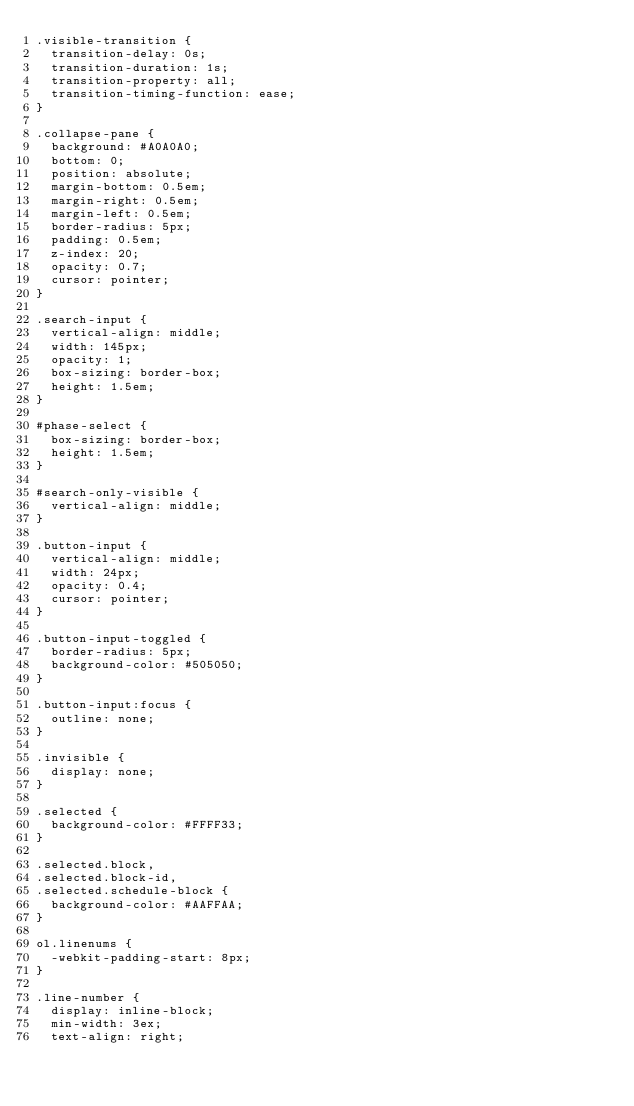Convert code to text. <code><loc_0><loc_0><loc_500><loc_500><_CSS_>.visible-transition {
  transition-delay: 0s;
  transition-duration: 1s;
  transition-property: all;
  transition-timing-function: ease;
}

.collapse-pane {
  background: #A0A0A0;
  bottom: 0;
  position: absolute;
  margin-bottom: 0.5em;
  margin-right: 0.5em;
  margin-left: 0.5em;
  border-radius: 5px;
  padding: 0.5em;
  z-index: 20;
  opacity: 0.7;
  cursor: pointer;
}

.search-input {
  vertical-align: middle;
  width: 145px;
  opacity: 1;
  box-sizing: border-box;
  height: 1.5em;
}

#phase-select {
  box-sizing: border-box;
  height: 1.5em;
}

#search-only-visible {
  vertical-align: middle;
}

.button-input {
  vertical-align: middle;
  width: 24px;
  opacity: 0.4;
  cursor: pointer;
}

.button-input-toggled {
  border-radius: 5px;
  background-color: #505050;
}

.button-input:focus {
  outline: none;
}

.invisible {
  display: none;
}

.selected {
  background-color: #FFFF33;
}

.selected.block,
.selected.block-id,
.selected.schedule-block {
  background-color: #AAFFAA;
}

ol.linenums {
  -webkit-padding-start: 8px;
}

.line-number {
  display: inline-block;
  min-width: 3ex;
  text-align: right;</code> 